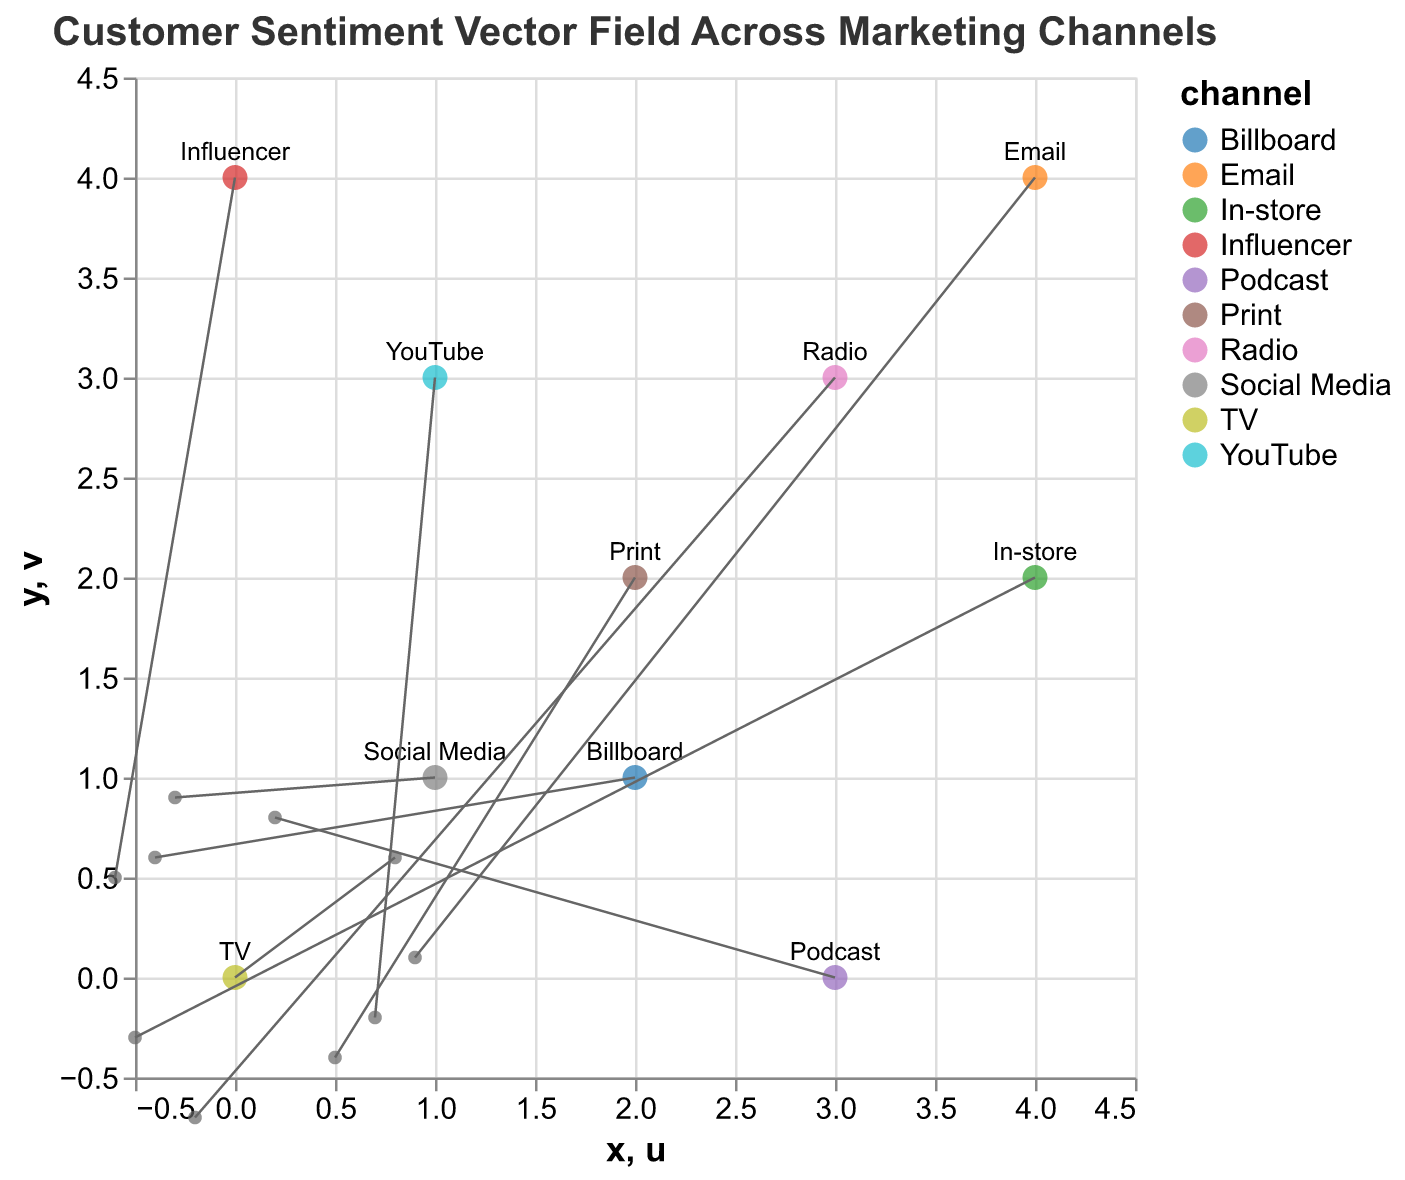What's the title of the figure? The title is typically placed at the top of the figure. In this case, it reads, "Customer Sentiment Vector Field Across Marketing Channels".
Answer: Customer Sentiment Vector Field Across Marketing Channels How many marketing channels are represented in the plot? Each data point is associated with a unique marketing channel which can be identified by the color or text labels in the plot. Counting the unique channels gives us 10: TV, Social Media, Print, Radio, Email, Influencer, YouTube, Billboard, Podcast, and In-store.
Answer: 10 Which data point shows the highest positive sentiment vector along the x-axis? The u (x-component) and v (y-component) values of the vectors determine the directions. The data point with the highest positive u value is for "Email" with u=0.9.
Answer: Email Which marketing channel shows a downward sentiment trend? A downward sentiment trend is indicated by a negative value in the v (y-component) of the vector. "Print" has a v value of -0.4, and "Radio" has a v value of -0.7. Among them, Radio has the greater downward trend.
Answer: Radio What is the x and y position of the Social Media channel? The tooltip information can be referred to for precise positioning. For Social Media, the x position is 1, and the y position is 1.
Answer: (1, 1) Compare the sentiment vector directions of TV and Social Media channels. Which one shows more upward sentiment? TV has vector components u=0.8, v=0.6, while Social Media has vector components u=-0.3, v=0.9. Looking at the v values which represent the y direction, Social Media has a higher v value (0.9 vs. 0.6) indicating a more upward sentiment.
Answer: Social Media What is the overall vector direction for the Billboard channel? The vector components for Billboard are u=-0.4 and v=0.6. This implies a general direction towards the left and upwards.
Answer: Left and Upwards For the Influencer channel, what is the numerical value of sentiment change in the y-direction? The v value for the Influencer channel is 0.5. This numerical value represents the sentiment change in the y-direction, or upwards trend.
Answer: 0.5 What's the vector direction for In-store marketing channel? The vector components are u=-0.5 and v=-0.3, indicating the sentiment is downward and to the left.
Answer: Downward and Left 